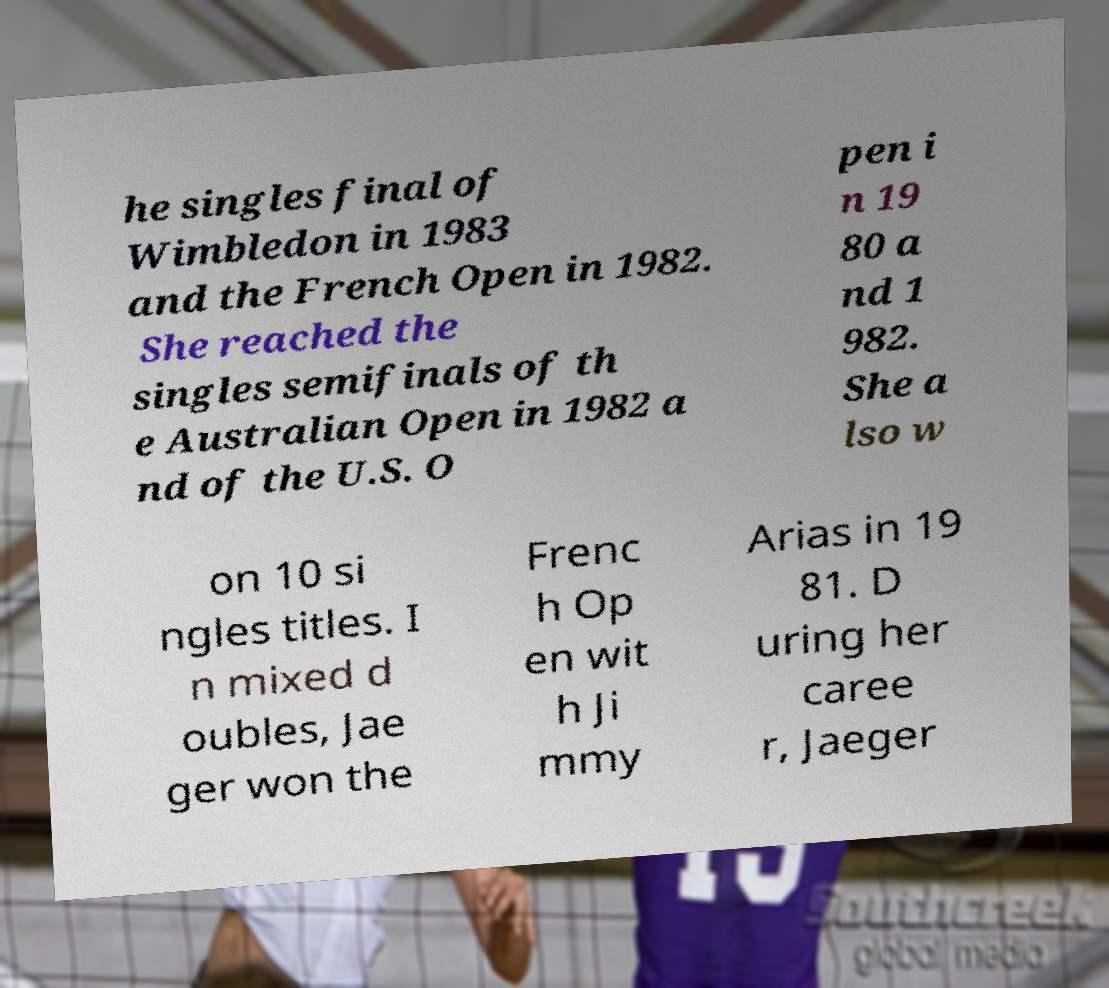Could you extract and type out the text from this image? he singles final of Wimbledon in 1983 and the French Open in 1982. She reached the singles semifinals of th e Australian Open in 1982 a nd of the U.S. O pen i n 19 80 a nd 1 982. She a lso w on 10 si ngles titles. I n mixed d oubles, Jae ger won the Frenc h Op en wit h Ji mmy Arias in 19 81. D uring her caree r, Jaeger 